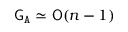Convert formula to latex. <formula><loc_0><loc_0><loc_500><loc_500>{ G } _ { A } \simeq { O } ( n - 1 )</formula> 